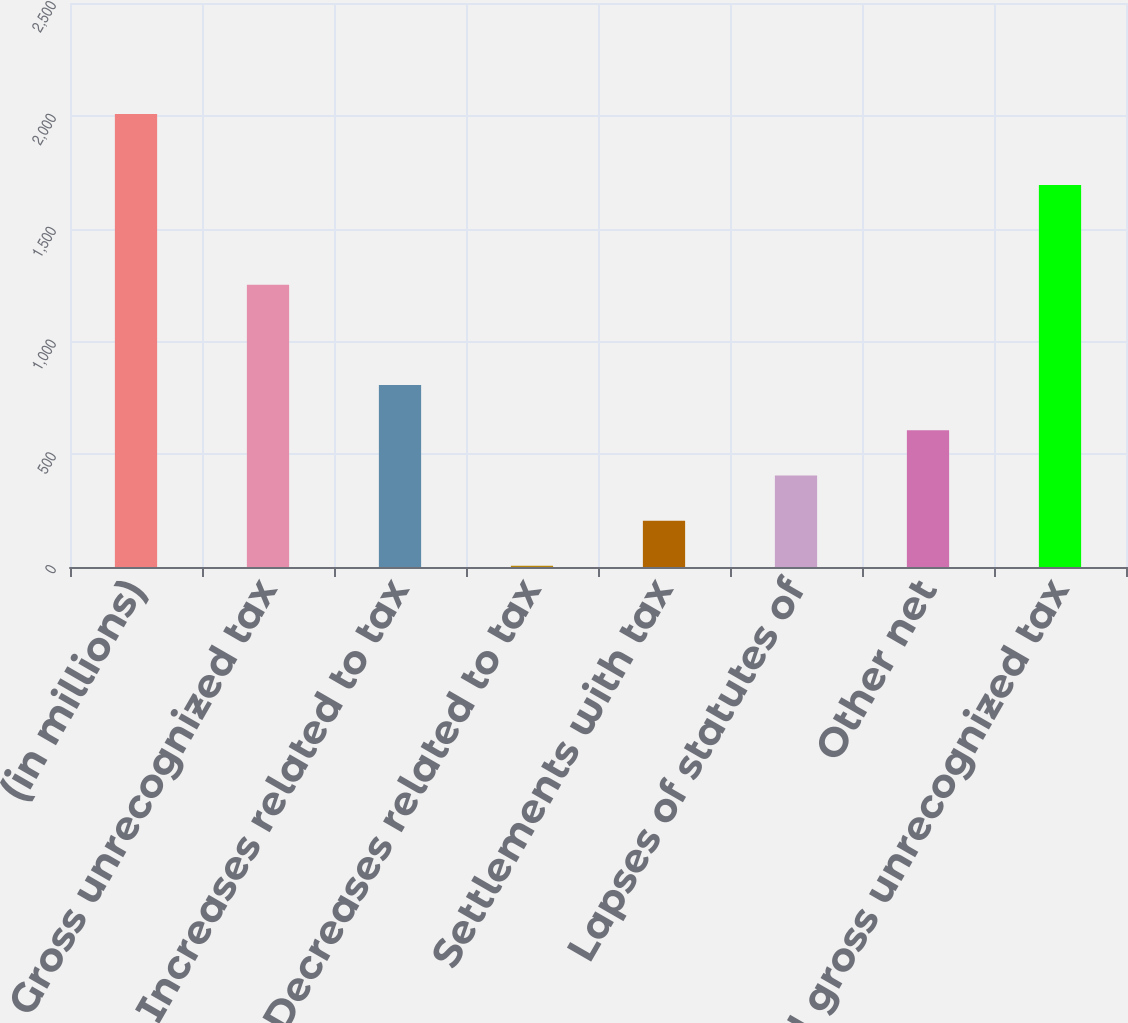<chart> <loc_0><loc_0><loc_500><loc_500><bar_chart><fcel>(in millions)<fcel>Gross unrecognized tax<fcel>Increases related to tax<fcel>Decreases related to tax<fcel>Settlements with tax<fcel>Lapses of statutes of<fcel>Other net<fcel>Total gross unrecognized tax<nl><fcel>2008<fcel>1251<fcel>806.2<fcel>5<fcel>205.3<fcel>405.6<fcel>605.9<fcel>1693<nl></chart> 